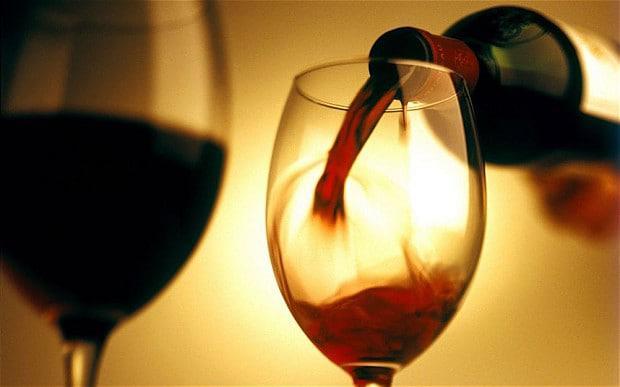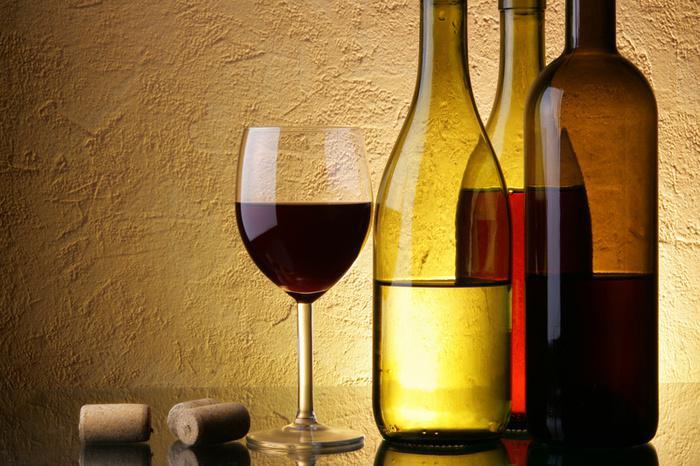The first image is the image on the left, the second image is the image on the right. Evaluate the accuracy of this statement regarding the images: "Wine is shown flowing from the bottle into the glass in exactly one image, and both images include a glass of wine and at least one bottle.". Is it true? Answer yes or no. Yes. 